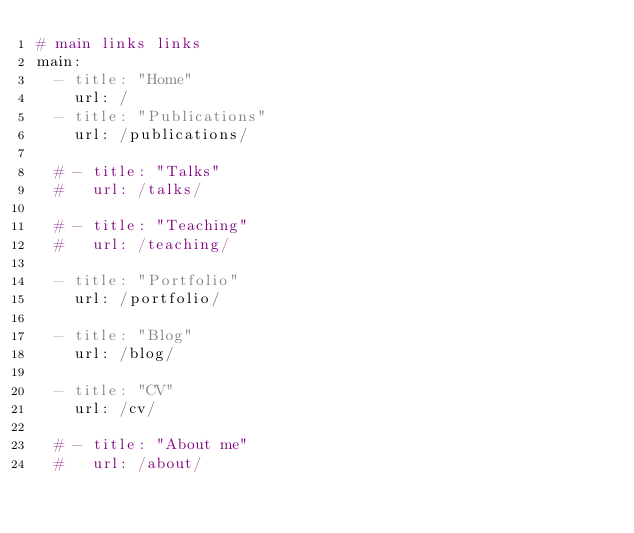<code> <loc_0><loc_0><loc_500><loc_500><_YAML_># main links links
main:
  - title: "Home"
    url: /
  - title: "Publications"
    url: /publications/

  # - title: "Talks"
  #   url: /talks/    

  # - title: "Teaching"
  #   url: /teaching/    
    
  - title: "Portfolio"
    url: /portfolio/
        
  - title: "Blog"
    url: /blog/
    
  - title: "CV"
    url: /cv/
    
  # - title: "About me"
  #   url: /about/
</code> 